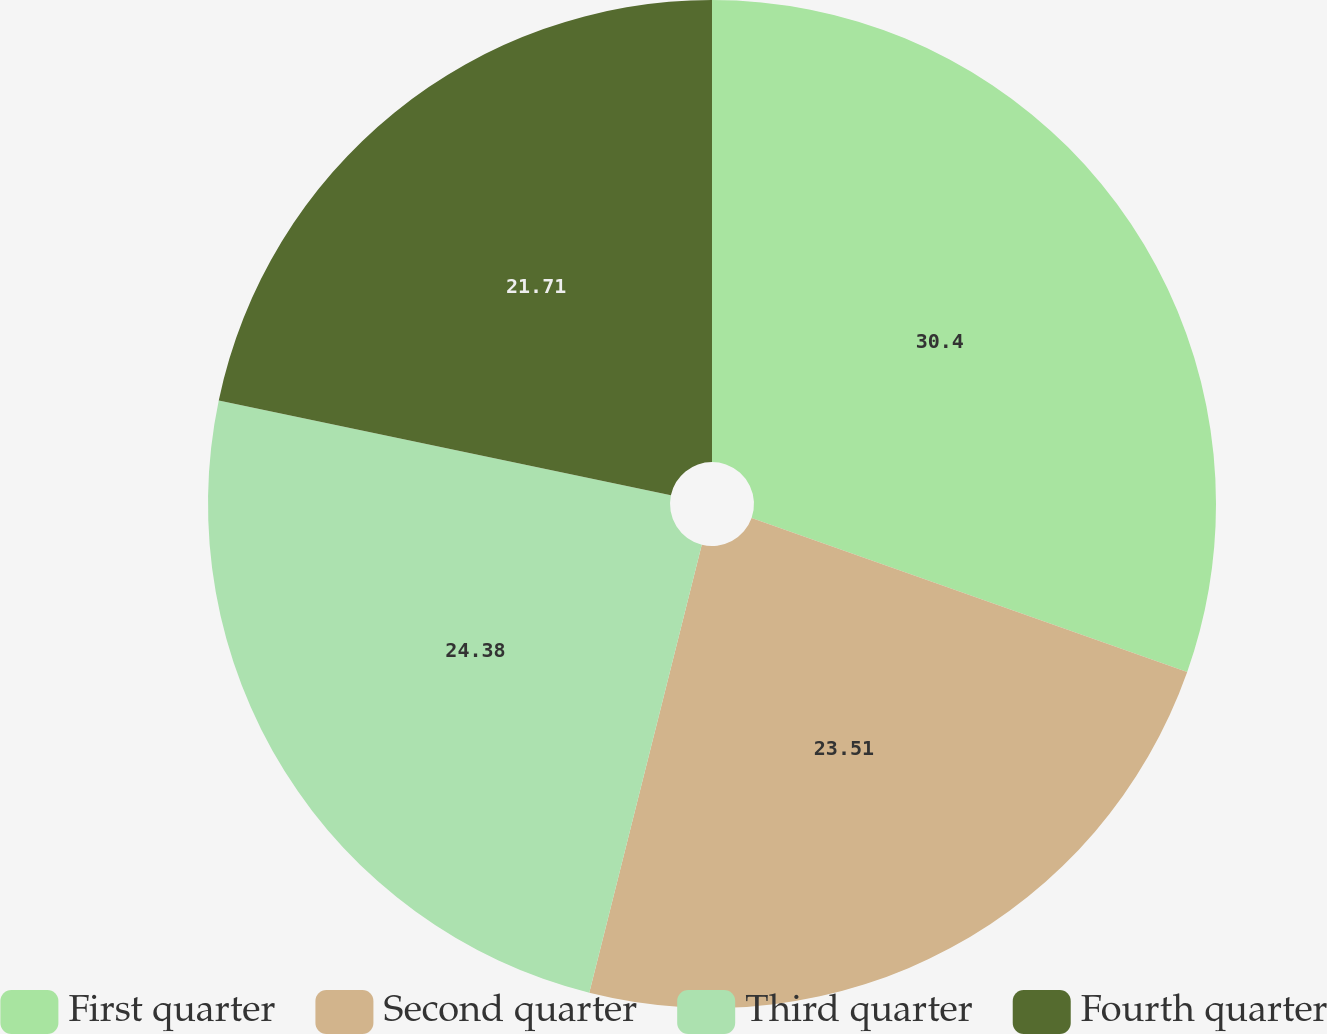Convert chart to OTSL. <chart><loc_0><loc_0><loc_500><loc_500><pie_chart><fcel>First quarter<fcel>Second quarter<fcel>Third quarter<fcel>Fourth quarter<nl><fcel>30.41%<fcel>23.51%<fcel>24.38%<fcel>21.71%<nl></chart> 